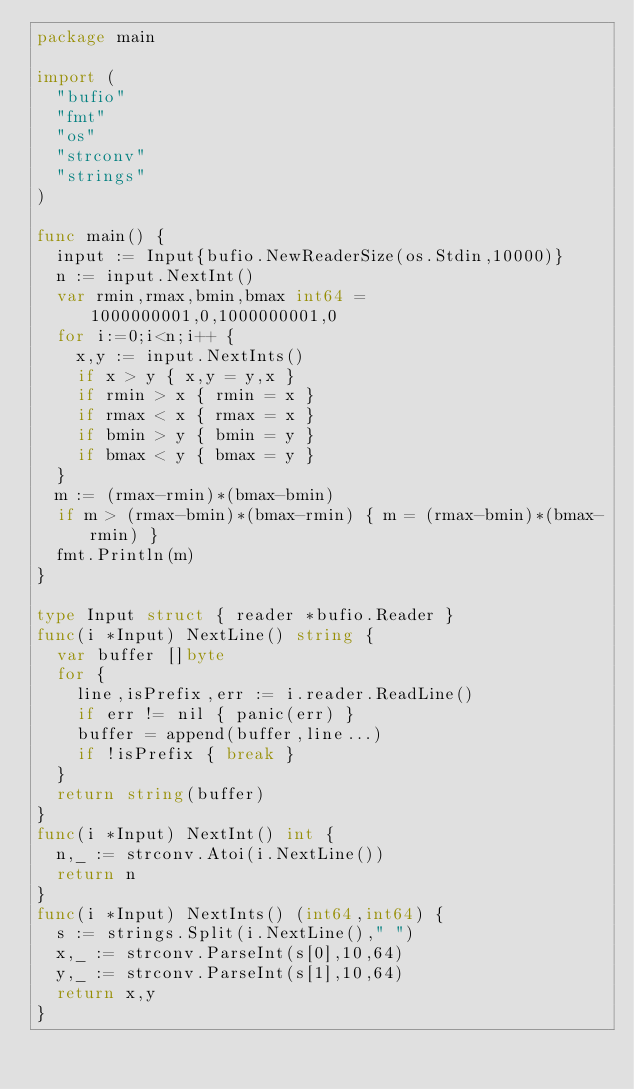Convert code to text. <code><loc_0><loc_0><loc_500><loc_500><_Go_>package main

import (
  "bufio"
  "fmt"
  "os"
  "strconv"
  "strings"
)

func main() {
  input := Input{bufio.NewReaderSize(os.Stdin,10000)}
  n := input.NextInt()
  var rmin,rmax,bmin,bmax int64 = 1000000001,0,1000000001,0
  for i:=0;i<n;i++ {
    x,y := input.NextInts()
    if x > y { x,y = y,x }
    if rmin > x { rmin = x }
    if rmax < x { rmax = x }
    if bmin > y { bmin = y }
    if bmax < y { bmax = y }
  }
  m := (rmax-rmin)*(bmax-bmin)
  if m > (rmax-bmin)*(bmax-rmin) { m = (rmax-bmin)*(bmax-rmin) }
  fmt.Println(m)
}

type Input struct { reader *bufio.Reader }
func(i *Input) NextLine() string {
  var buffer []byte
  for {
    line,isPrefix,err := i.reader.ReadLine()
    if err != nil { panic(err) }
    buffer = append(buffer,line...)
    if !isPrefix { break }
  }
  return string(buffer)
}
func(i *Input) NextInt() int {
  n,_ := strconv.Atoi(i.NextLine())
  return n
}
func(i *Input) NextInts() (int64,int64) {
  s := strings.Split(i.NextLine()," ")
  x,_ := strconv.ParseInt(s[0],10,64)
  y,_ := strconv.ParseInt(s[1],10,64)
  return x,y
}</code> 